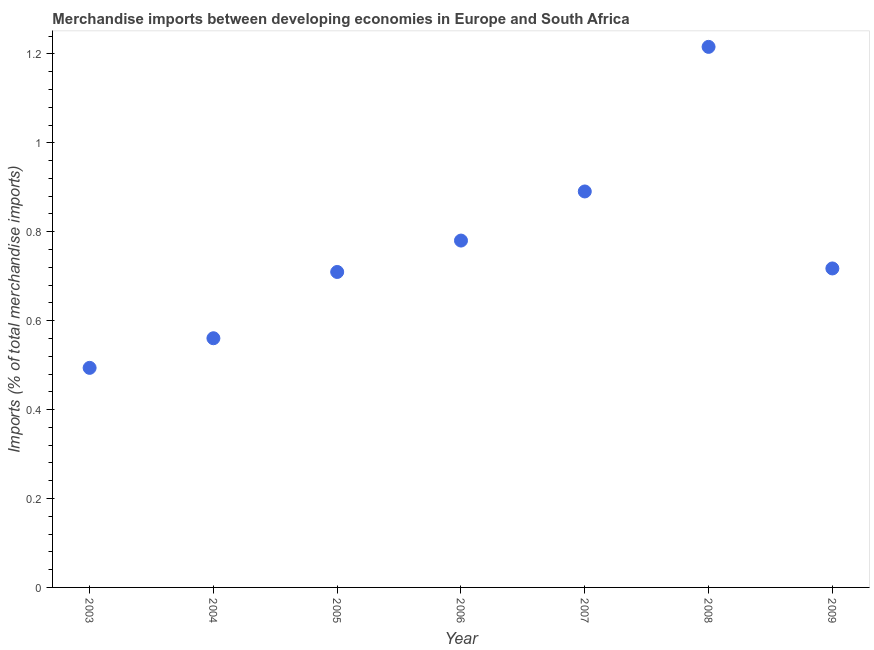What is the merchandise imports in 2009?
Provide a succinct answer. 0.72. Across all years, what is the maximum merchandise imports?
Provide a short and direct response. 1.22. Across all years, what is the minimum merchandise imports?
Your answer should be very brief. 0.49. In which year was the merchandise imports maximum?
Your response must be concise. 2008. In which year was the merchandise imports minimum?
Provide a short and direct response. 2003. What is the sum of the merchandise imports?
Keep it short and to the point. 5.37. What is the difference between the merchandise imports in 2005 and 2009?
Offer a terse response. -0.01. What is the average merchandise imports per year?
Your answer should be very brief. 0.77. What is the median merchandise imports?
Offer a terse response. 0.72. In how many years, is the merchandise imports greater than 0.32 %?
Offer a very short reply. 7. Do a majority of the years between 2004 and 2003 (inclusive) have merchandise imports greater than 1.12 %?
Your answer should be compact. No. What is the ratio of the merchandise imports in 2003 to that in 2009?
Your response must be concise. 0.69. Is the merchandise imports in 2003 less than that in 2008?
Provide a succinct answer. Yes. Is the difference between the merchandise imports in 2006 and 2007 greater than the difference between any two years?
Make the answer very short. No. What is the difference between the highest and the second highest merchandise imports?
Provide a short and direct response. 0.33. What is the difference between the highest and the lowest merchandise imports?
Give a very brief answer. 0.72. In how many years, is the merchandise imports greater than the average merchandise imports taken over all years?
Keep it short and to the point. 3. How many dotlines are there?
Provide a succinct answer. 1. How many years are there in the graph?
Make the answer very short. 7. What is the difference between two consecutive major ticks on the Y-axis?
Your response must be concise. 0.2. Are the values on the major ticks of Y-axis written in scientific E-notation?
Keep it short and to the point. No. Does the graph contain any zero values?
Offer a terse response. No. What is the title of the graph?
Give a very brief answer. Merchandise imports between developing economies in Europe and South Africa. What is the label or title of the Y-axis?
Keep it short and to the point. Imports (% of total merchandise imports). What is the Imports (% of total merchandise imports) in 2003?
Your answer should be compact. 0.49. What is the Imports (% of total merchandise imports) in 2004?
Keep it short and to the point. 0.56. What is the Imports (% of total merchandise imports) in 2005?
Offer a terse response. 0.71. What is the Imports (% of total merchandise imports) in 2006?
Your answer should be very brief. 0.78. What is the Imports (% of total merchandise imports) in 2007?
Offer a very short reply. 0.89. What is the Imports (% of total merchandise imports) in 2008?
Provide a short and direct response. 1.22. What is the Imports (% of total merchandise imports) in 2009?
Your answer should be very brief. 0.72. What is the difference between the Imports (% of total merchandise imports) in 2003 and 2004?
Give a very brief answer. -0.07. What is the difference between the Imports (% of total merchandise imports) in 2003 and 2005?
Your answer should be very brief. -0.22. What is the difference between the Imports (% of total merchandise imports) in 2003 and 2006?
Offer a terse response. -0.29. What is the difference between the Imports (% of total merchandise imports) in 2003 and 2007?
Offer a terse response. -0.4. What is the difference between the Imports (% of total merchandise imports) in 2003 and 2008?
Offer a terse response. -0.72. What is the difference between the Imports (% of total merchandise imports) in 2003 and 2009?
Provide a short and direct response. -0.22. What is the difference between the Imports (% of total merchandise imports) in 2004 and 2005?
Offer a very short reply. -0.15. What is the difference between the Imports (% of total merchandise imports) in 2004 and 2006?
Ensure brevity in your answer.  -0.22. What is the difference between the Imports (% of total merchandise imports) in 2004 and 2007?
Your answer should be very brief. -0.33. What is the difference between the Imports (% of total merchandise imports) in 2004 and 2008?
Provide a succinct answer. -0.66. What is the difference between the Imports (% of total merchandise imports) in 2004 and 2009?
Offer a very short reply. -0.16. What is the difference between the Imports (% of total merchandise imports) in 2005 and 2006?
Keep it short and to the point. -0.07. What is the difference between the Imports (% of total merchandise imports) in 2005 and 2007?
Your answer should be compact. -0.18. What is the difference between the Imports (% of total merchandise imports) in 2005 and 2008?
Make the answer very short. -0.51. What is the difference between the Imports (% of total merchandise imports) in 2005 and 2009?
Offer a very short reply. -0.01. What is the difference between the Imports (% of total merchandise imports) in 2006 and 2007?
Keep it short and to the point. -0.11. What is the difference between the Imports (% of total merchandise imports) in 2006 and 2008?
Provide a short and direct response. -0.44. What is the difference between the Imports (% of total merchandise imports) in 2006 and 2009?
Offer a terse response. 0.06. What is the difference between the Imports (% of total merchandise imports) in 2007 and 2008?
Make the answer very short. -0.33. What is the difference between the Imports (% of total merchandise imports) in 2007 and 2009?
Provide a short and direct response. 0.17. What is the difference between the Imports (% of total merchandise imports) in 2008 and 2009?
Your response must be concise. 0.5. What is the ratio of the Imports (% of total merchandise imports) in 2003 to that in 2004?
Offer a terse response. 0.88. What is the ratio of the Imports (% of total merchandise imports) in 2003 to that in 2005?
Keep it short and to the point. 0.7. What is the ratio of the Imports (% of total merchandise imports) in 2003 to that in 2006?
Make the answer very short. 0.63. What is the ratio of the Imports (% of total merchandise imports) in 2003 to that in 2007?
Offer a very short reply. 0.56. What is the ratio of the Imports (% of total merchandise imports) in 2003 to that in 2008?
Give a very brief answer. 0.41. What is the ratio of the Imports (% of total merchandise imports) in 2003 to that in 2009?
Your answer should be compact. 0.69. What is the ratio of the Imports (% of total merchandise imports) in 2004 to that in 2005?
Provide a short and direct response. 0.79. What is the ratio of the Imports (% of total merchandise imports) in 2004 to that in 2006?
Give a very brief answer. 0.72. What is the ratio of the Imports (% of total merchandise imports) in 2004 to that in 2007?
Your response must be concise. 0.63. What is the ratio of the Imports (% of total merchandise imports) in 2004 to that in 2008?
Provide a short and direct response. 0.46. What is the ratio of the Imports (% of total merchandise imports) in 2004 to that in 2009?
Ensure brevity in your answer.  0.78. What is the ratio of the Imports (% of total merchandise imports) in 2005 to that in 2006?
Your response must be concise. 0.91. What is the ratio of the Imports (% of total merchandise imports) in 2005 to that in 2007?
Make the answer very short. 0.8. What is the ratio of the Imports (% of total merchandise imports) in 2005 to that in 2008?
Your answer should be very brief. 0.58. What is the ratio of the Imports (% of total merchandise imports) in 2005 to that in 2009?
Provide a short and direct response. 0.99. What is the ratio of the Imports (% of total merchandise imports) in 2006 to that in 2007?
Give a very brief answer. 0.88. What is the ratio of the Imports (% of total merchandise imports) in 2006 to that in 2008?
Make the answer very short. 0.64. What is the ratio of the Imports (% of total merchandise imports) in 2006 to that in 2009?
Give a very brief answer. 1.09. What is the ratio of the Imports (% of total merchandise imports) in 2007 to that in 2008?
Provide a succinct answer. 0.73. What is the ratio of the Imports (% of total merchandise imports) in 2007 to that in 2009?
Your answer should be very brief. 1.24. What is the ratio of the Imports (% of total merchandise imports) in 2008 to that in 2009?
Your answer should be compact. 1.7. 